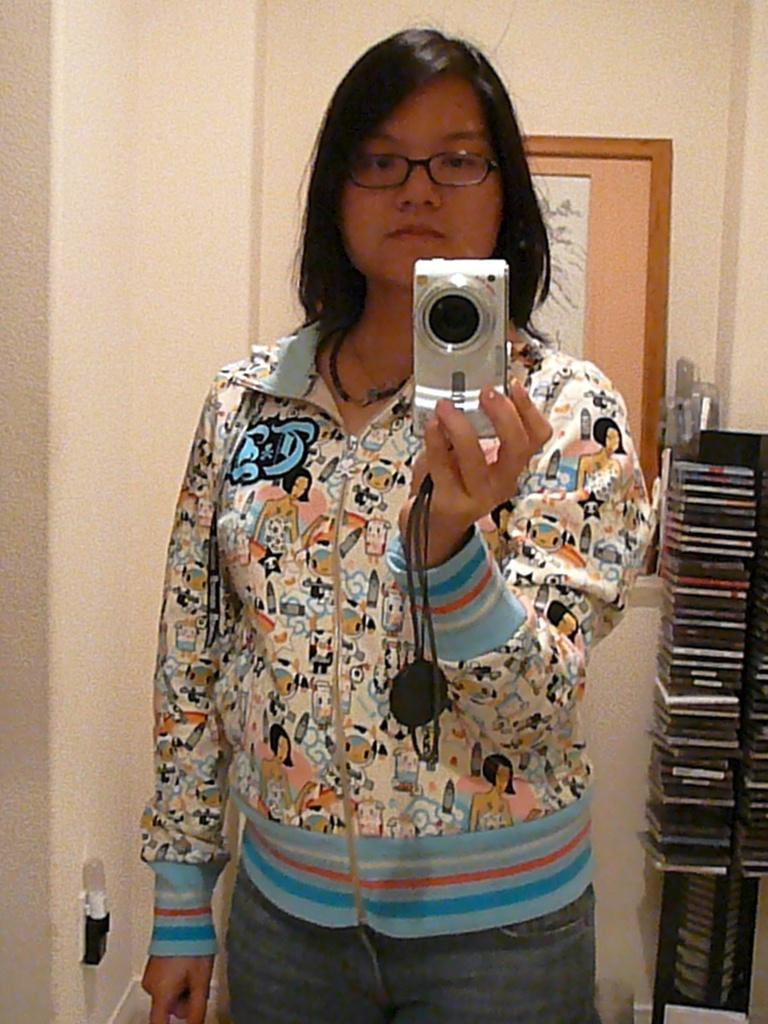In one or two sentences, can you explain what this image depicts? Here we can see a woman standing and holding a camera in her hands, and at back here is the wall and photo frame on it. 